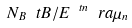<formula> <loc_0><loc_0><loc_500><loc_500>N _ { B } \ t B / E ^ { \ t n } \ r a \mu _ { n }</formula> 